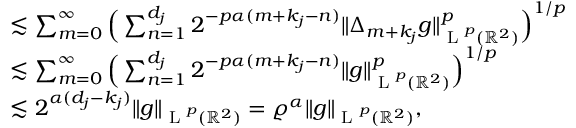<formula> <loc_0><loc_0><loc_500><loc_500>\begin{array} { r l } & { \lesssim \sum _ { m = 0 } ^ { \infty } \left ( \sum _ { n = 1 } ^ { d _ { j } } 2 ^ { - p \alpha ( m + k _ { j } - n ) } \| \Delta _ { m + k _ { j } } g \| _ { L ^ { p } ( \mathbb { R } ^ { 2 } ) } ^ { p } \right ) ^ { 1 / p } } \\ & { \lesssim \sum _ { m = 0 } ^ { \infty } \left ( \sum _ { n = 1 } ^ { d _ { j } } 2 ^ { - p \alpha ( m + k _ { j } - n ) } \| g \| _ { L ^ { p } ( \mathbb { R } ^ { 2 } ) } ^ { p } \right ) ^ { 1 / p } } \\ & { \lesssim 2 ^ { \alpha ( d _ { j } - k _ { j } ) } \| g \| _ { L ^ { p } ( \mathbb { R } ^ { 2 } ) } = \varrho ^ { \alpha } \| g \| _ { L ^ { p } ( \mathbb { R } ^ { 2 } ) } , } \end{array}</formula> 